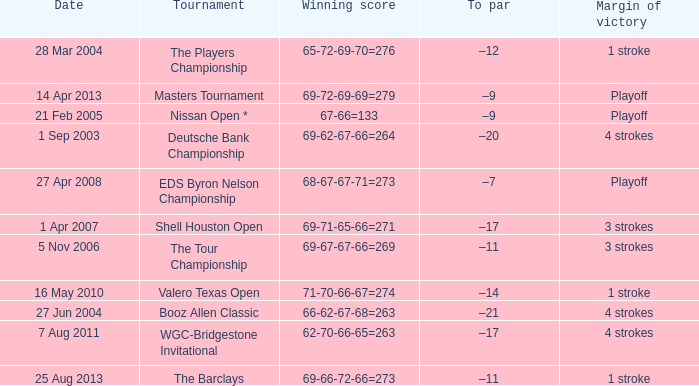Which date has a To par of –12? 28 Mar 2004. 